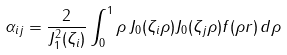Convert formula to latex. <formula><loc_0><loc_0><loc_500><loc_500>\alpha _ { i j } = \frac { 2 } { J _ { 1 } ^ { 2 } ( \zeta _ { i } ) } \int _ { 0 } ^ { 1 } \rho \, J _ { 0 } ( \zeta _ { i } \rho ) J _ { 0 } ( \zeta _ { j } \rho ) f ( \rho r ) \, d \rho</formula> 